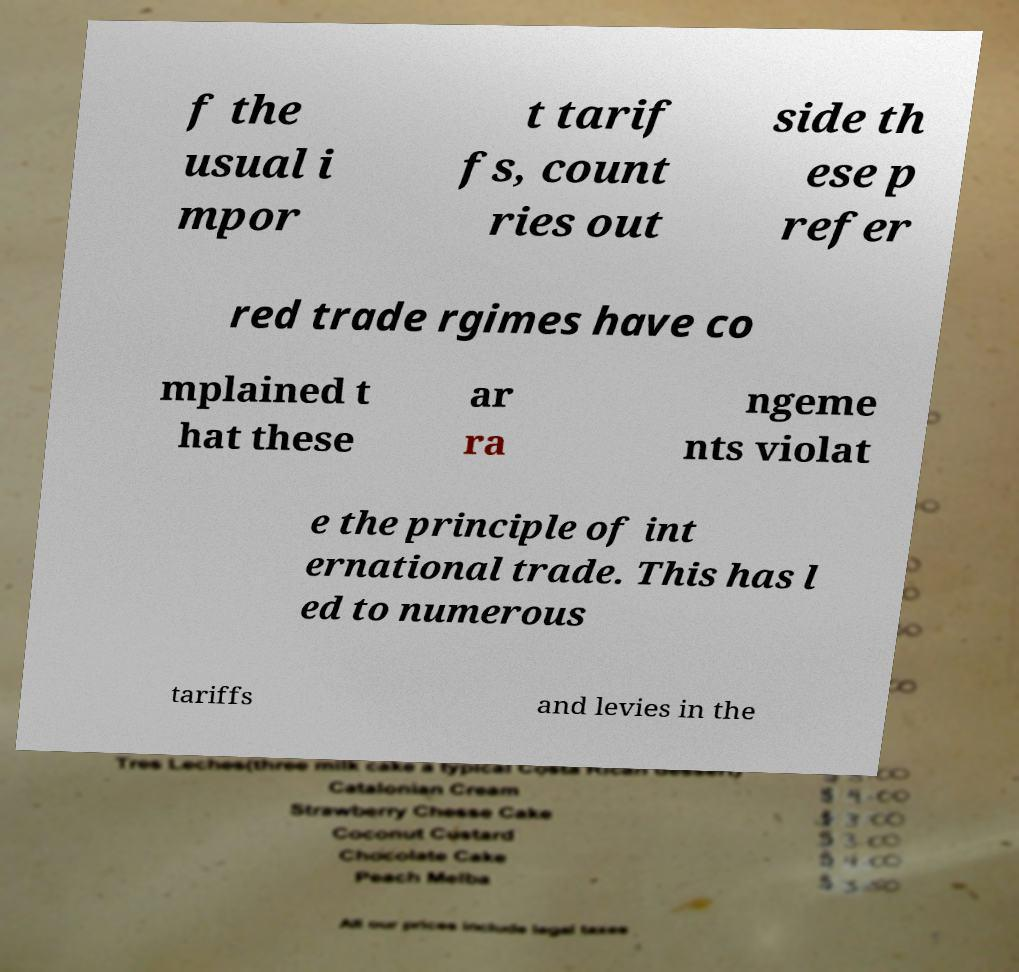Please identify and transcribe the text found in this image. f the usual i mpor t tarif fs, count ries out side th ese p refer red trade rgimes have co mplained t hat these ar ra ngeme nts violat e the principle of int ernational trade. This has l ed to numerous tariffs and levies in the 